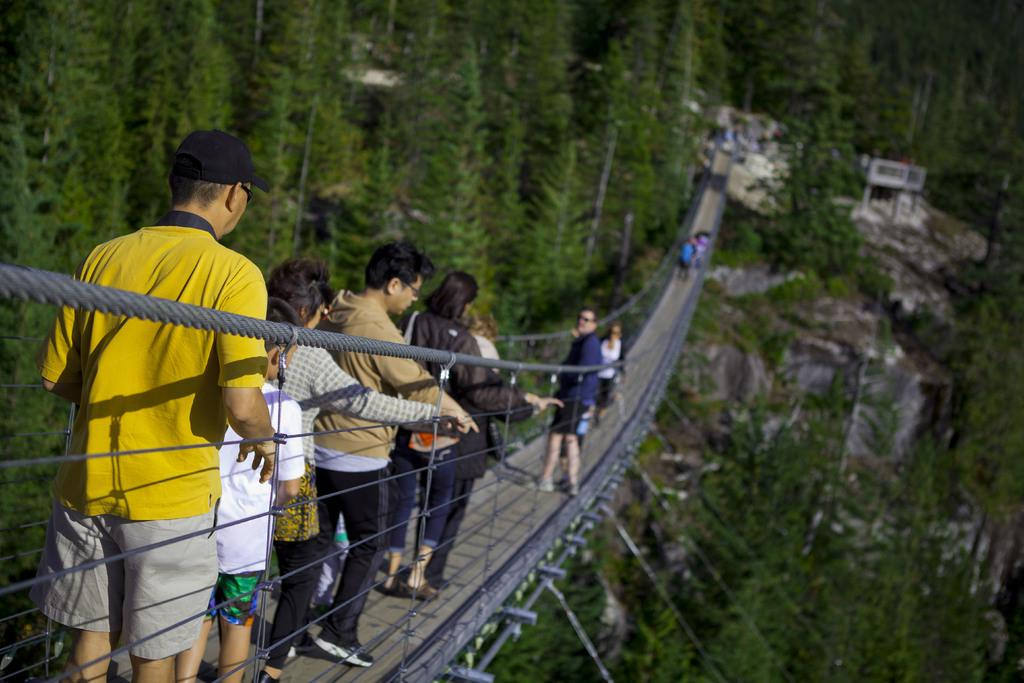What can be seen on the bridge in the image? There are people on the bridge in the image. What is visible in the background of the image? There are trees visible in the background of the image. What type of liquid is being attempted to be poured by the people on the bridge in the image? There is no liquid or attempt to pour anything visible in the image; it only shows people on the bridge and trees in the background. 